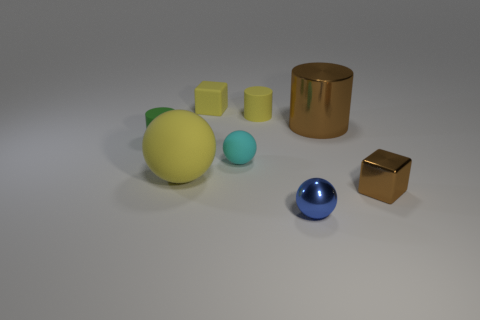There is a big ball; is it the same color as the block that is to the left of the brown block?
Your response must be concise. Yes. There is a blue ball in front of the brown object that is right of the cylinder on the right side of the small metal ball; what is it made of?
Ensure brevity in your answer.  Metal. There is a brown object that is the same size as the matte cube; what is it made of?
Make the answer very short. Metal. Is the number of tiny cyan matte balls behind the small cyan rubber sphere the same as the number of tiny yellow objects to the left of the tiny metal ball?
Make the answer very short. No. What number of other objects are the same color as the tiny matte ball?
Keep it short and to the point. 0. Is the number of tiny blocks that are to the left of the small green rubber cylinder the same as the number of big blue metal balls?
Provide a succinct answer. Yes. Does the metallic ball have the same size as the brown cylinder?
Make the answer very short. No. What is the ball that is right of the big ball and behind the small brown object made of?
Offer a terse response. Rubber. What number of tiny metallic things have the same shape as the small cyan rubber object?
Make the answer very short. 1. There is a yellow thing on the left side of the yellow block; what is it made of?
Offer a terse response. Rubber. 